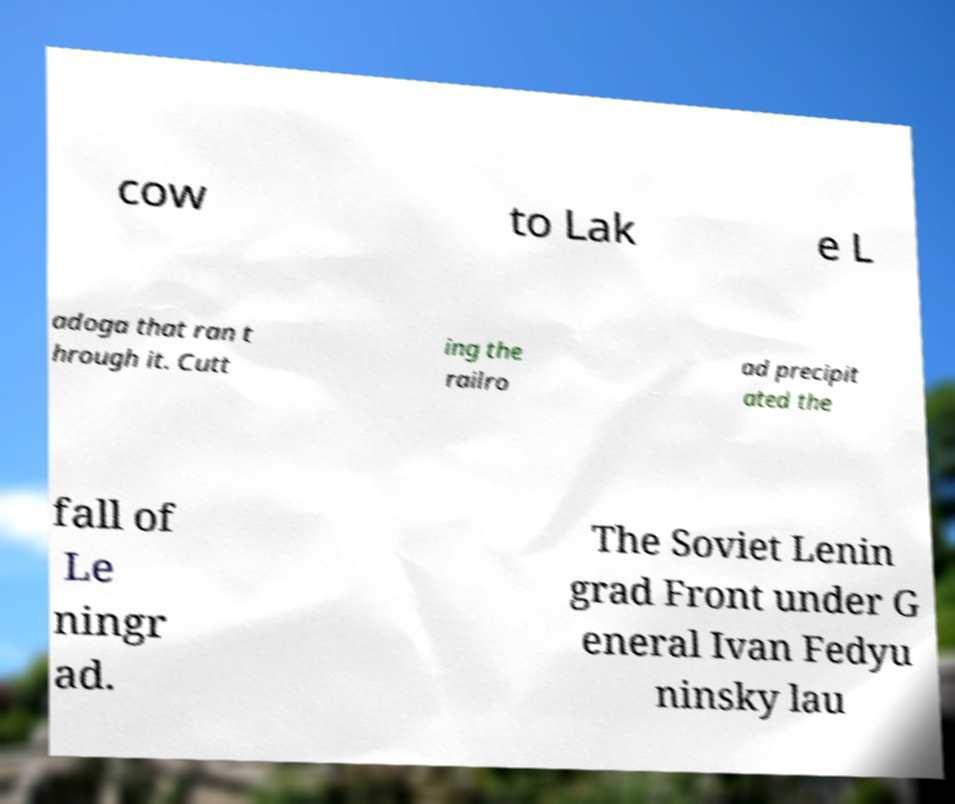What messages or text are displayed in this image? I need them in a readable, typed format. cow to Lak e L adoga that ran t hrough it. Cutt ing the railro ad precipit ated the fall of Le ningr ad. The Soviet Lenin grad Front under G eneral Ivan Fedyu ninsky lau 